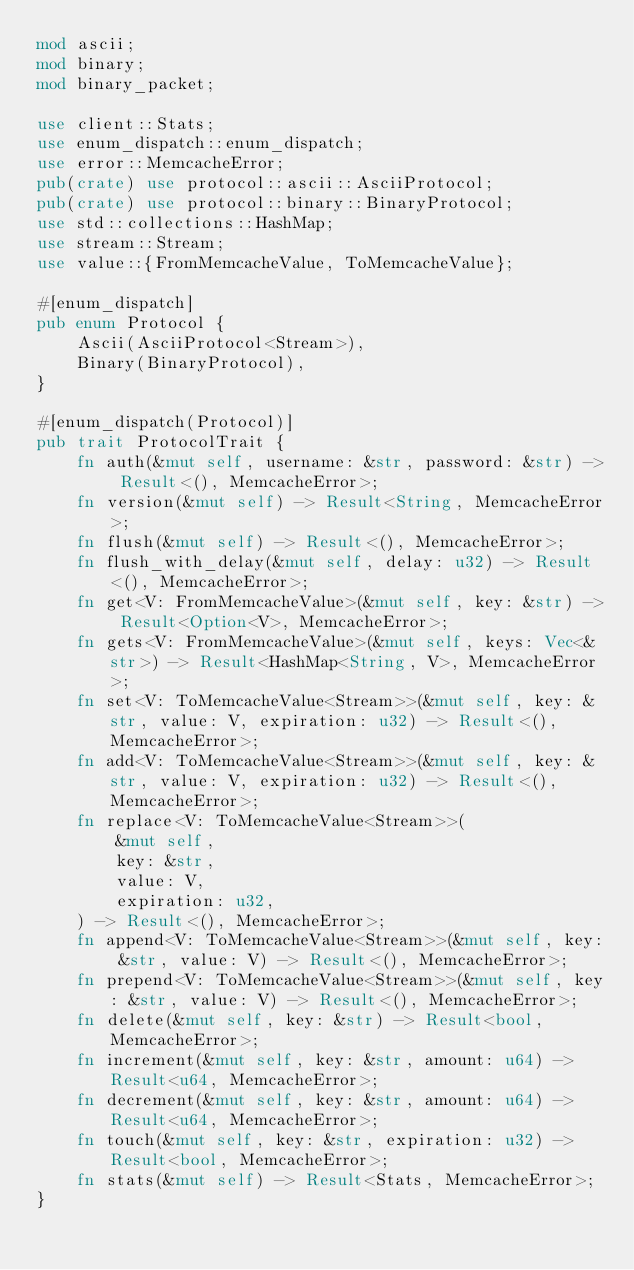<code> <loc_0><loc_0><loc_500><loc_500><_Rust_>mod ascii;
mod binary;
mod binary_packet;

use client::Stats;
use enum_dispatch::enum_dispatch;
use error::MemcacheError;
pub(crate) use protocol::ascii::AsciiProtocol;
pub(crate) use protocol::binary::BinaryProtocol;
use std::collections::HashMap;
use stream::Stream;
use value::{FromMemcacheValue, ToMemcacheValue};

#[enum_dispatch]
pub enum Protocol {
    Ascii(AsciiProtocol<Stream>),
    Binary(BinaryProtocol),
}

#[enum_dispatch(Protocol)]
pub trait ProtocolTrait {
    fn auth(&mut self, username: &str, password: &str) -> Result<(), MemcacheError>;
    fn version(&mut self) -> Result<String, MemcacheError>;
    fn flush(&mut self) -> Result<(), MemcacheError>;
    fn flush_with_delay(&mut self, delay: u32) -> Result<(), MemcacheError>;
    fn get<V: FromMemcacheValue>(&mut self, key: &str) -> Result<Option<V>, MemcacheError>;
    fn gets<V: FromMemcacheValue>(&mut self, keys: Vec<&str>) -> Result<HashMap<String, V>, MemcacheError>;
    fn set<V: ToMemcacheValue<Stream>>(&mut self, key: &str, value: V, expiration: u32) -> Result<(), MemcacheError>;
    fn add<V: ToMemcacheValue<Stream>>(&mut self, key: &str, value: V, expiration: u32) -> Result<(), MemcacheError>;
    fn replace<V: ToMemcacheValue<Stream>>(
        &mut self,
        key: &str,
        value: V,
        expiration: u32,
    ) -> Result<(), MemcacheError>;
    fn append<V: ToMemcacheValue<Stream>>(&mut self, key: &str, value: V) -> Result<(), MemcacheError>;
    fn prepend<V: ToMemcacheValue<Stream>>(&mut self, key: &str, value: V) -> Result<(), MemcacheError>;
    fn delete(&mut self, key: &str) -> Result<bool, MemcacheError>;
    fn increment(&mut self, key: &str, amount: u64) -> Result<u64, MemcacheError>;
    fn decrement(&mut self, key: &str, amount: u64) -> Result<u64, MemcacheError>;
    fn touch(&mut self, key: &str, expiration: u32) -> Result<bool, MemcacheError>;
    fn stats(&mut self) -> Result<Stats, MemcacheError>;
}
</code> 